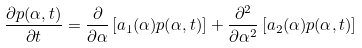Convert formula to latex. <formula><loc_0><loc_0><loc_500><loc_500>\frac { \partial p ( \alpha , t ) } { \partial t } = \frac { \partial } { \partial \alpha } \left [ a _ { 1 } ( \alpha ) p ( \alpha , t ) \right ] + \frac { \partial ^ { 2 } } { \partial \alpha ^ { 2 } } \left [ a _ { 2 } ( \alpha ) p ( \alpha , t ) \right ]</formula> 